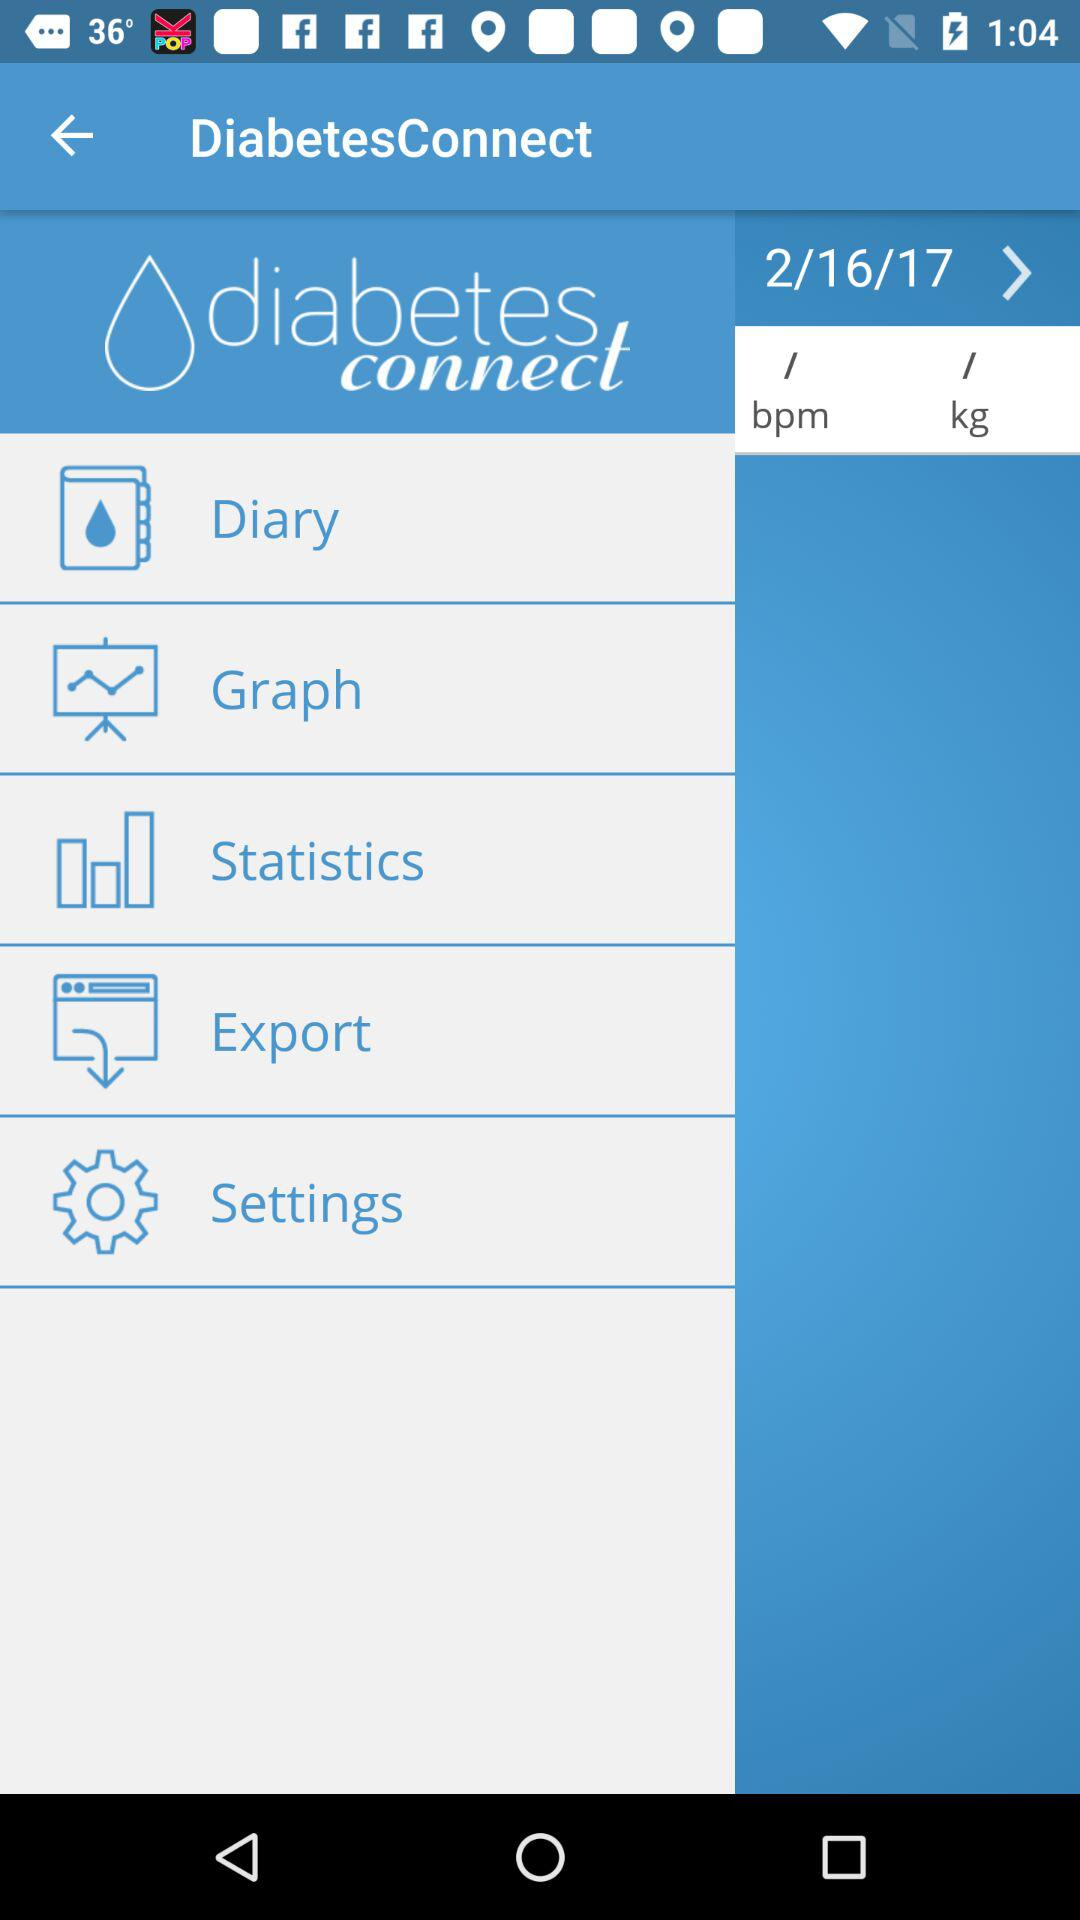What is the application name? The application name is "DiabetesConnect". 